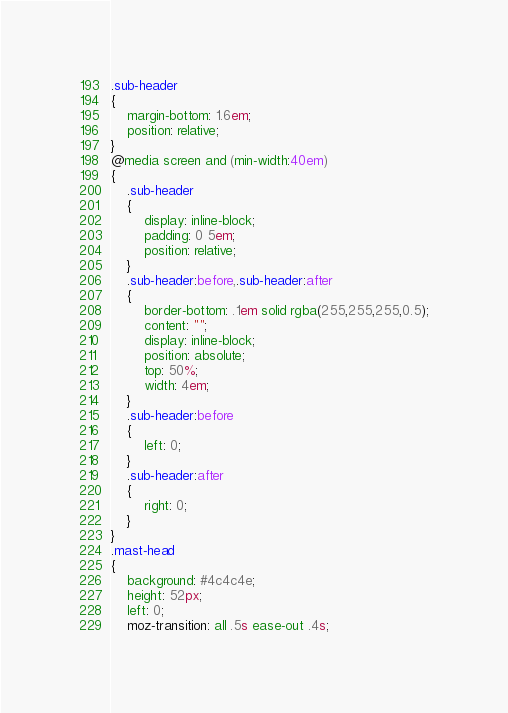<code> <loc_0><loc_0><loc_500><loc_500><_CSS_>.sub-header
{
	margin-bottom: 1.6em;
	position: relative;
}
@media screen and (min-width:40em)
{
	.sub-header
	{
		display: inline-block;
		padding: 0 5em;
		position: relative;
	}
	.sub-header:before,.sub-header:after
	{
		border-bottom: .1em solid rgba(255,255,255,0.5);
		content: "";
		display: inline-block;
		position: absolute;
		top: 50%;
		width: 4em;
	}
	.sub-header:before
	{
		left: 0;
	}
	.sub-header:after
	{
		right: 0;
	}
}
.mast-head
{
	background: #4c4c4e;
	height: 52px;
	left: 0;
	moz-transition: all .5s ease-out .4s;</code> 